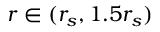Convert formula to latex. <formula><loc_0><loc_0><loc_500><loc_500>r \in ( r _ { s } , 1 . 5 r _ { s } )</formula> 